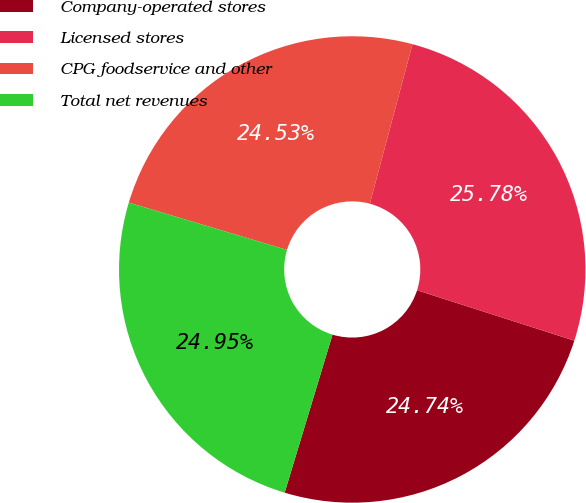Convert chart. <chart><loc_0><loc_0><loc_500><loc_500><pie_chart><fcel>Company-operated stores<fcel>Licensed stores<fcel>CPG foodservice and other<fcel>Total net revenues<nl><fcel>24.74%<fcel>25.78%<fcel>24.53%<fcel>24.95%<nl></chart> 